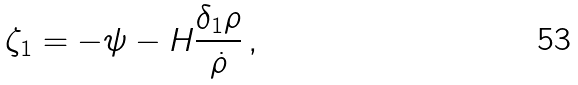<formula> <loc_0><loc_0><loc_500><loc_500>\zeta _ { 1 } = - \psi - H \frac { \delta _ { 1 } \rho } { \dot { \rho } } \, ,</formula> 